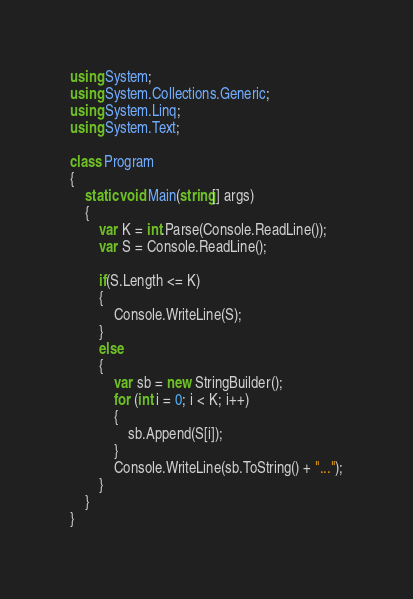Convert code to text. <code><loc_0><loc_0><loc_500><loc_500><_C#_>using System;
using System.Collections.Generic;
using System.Linq;
using System.Text;

class Program
{
    static void Main(string[] args)
    {
        var K = int.Parse(Console.ReadLine());
        var S = Console.ReadLine();

        if(S.Length <= K)
        {
            Console.WriteLine(S);
        }
        else
        {
            var sb = new StringBuilder();
            for (int i = 0; i < K; i++)
            {
                sb.Append(S[i]);
            }
            Console.WriteLine(sb.ToString() + "...");
        }
    }
}
</code> 